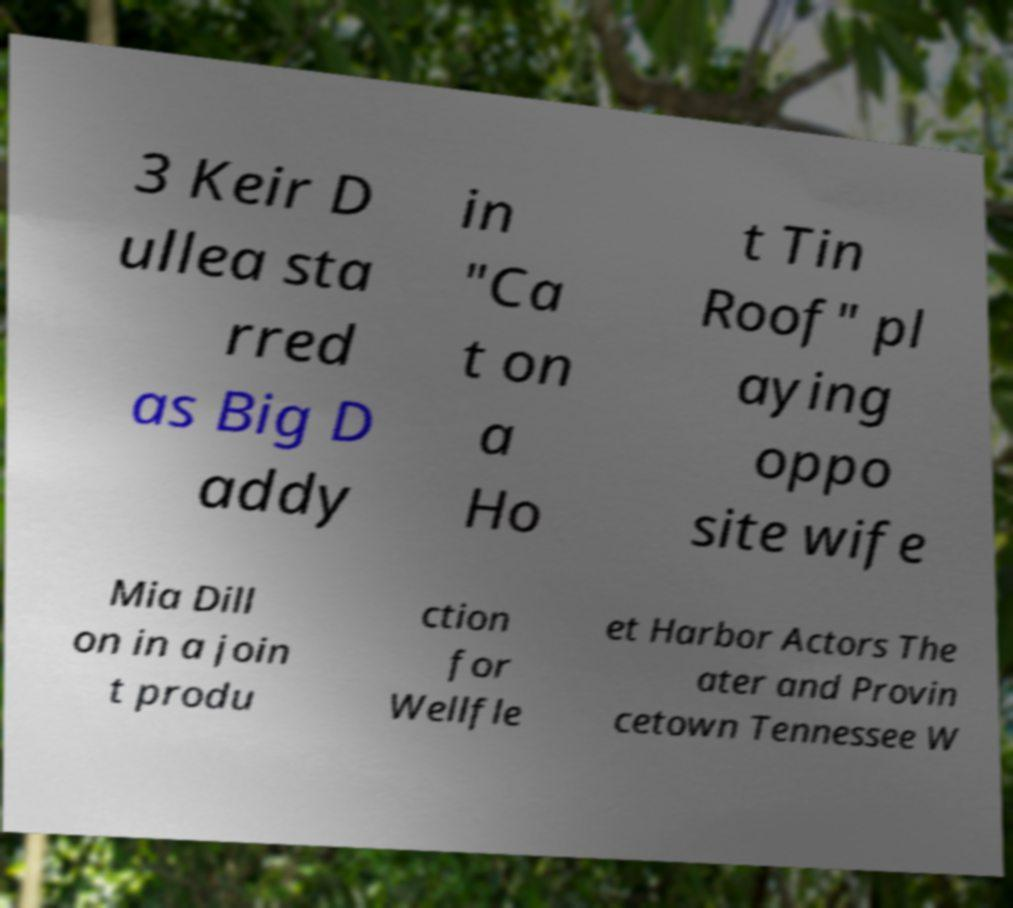Please identify and transcribe the text found in this image. 3 Keir D ullea sta rred as Big D addy in "Ca t on a Ho t Tin Roof" pl aying oppo site wife Mia Dill on in a join t produ ction for Wellfle et Harbor Actors The ater and Provin cetown Tennessee W 